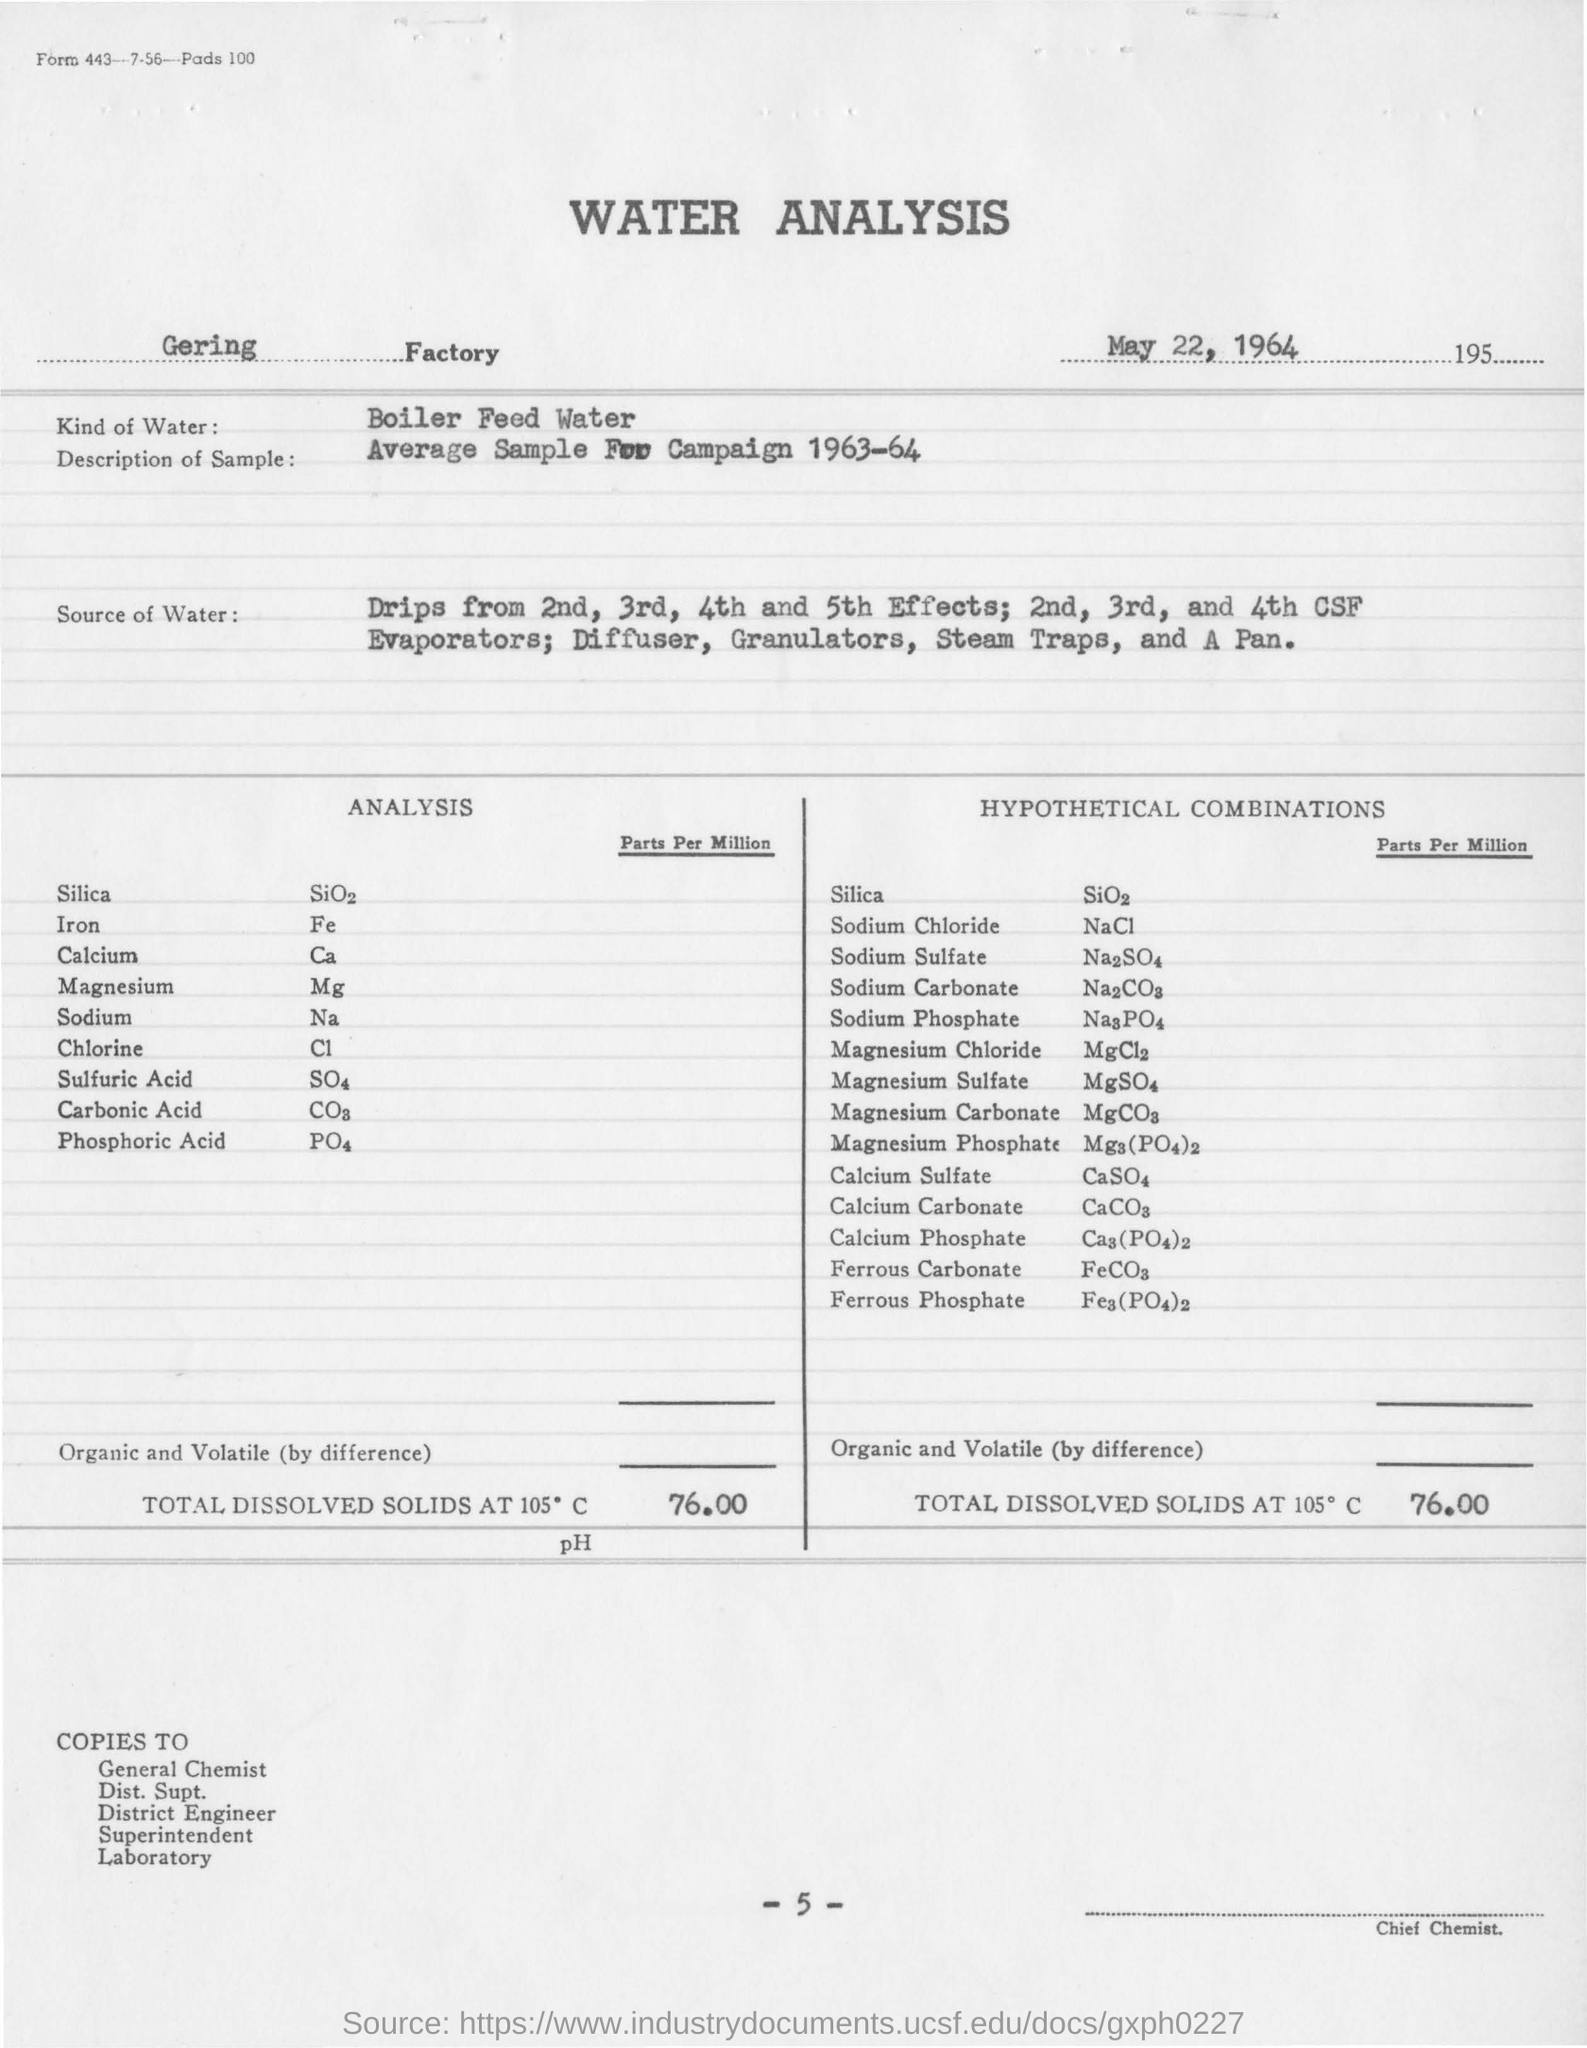Indicate a few pertinent items in this graphic. The type of water used for analysis in this study is bioler feed water. The name of the factory is Gering factory. The type of water used in analysis is typically boiler feed water. The amount of total dissolved solids at 105 degrees Celsius is 76.00. 